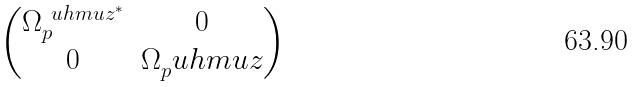<formula> <loc_0><loc_0><loc_500><loc_500>\begin{pmatrix} \Omega _ { p } ^ { \ u h m u z ^ { * } } & 0 \\ 0 & \Omega _ { p } ^ { \ } u h m u z \end{pmatrix}</formula> 